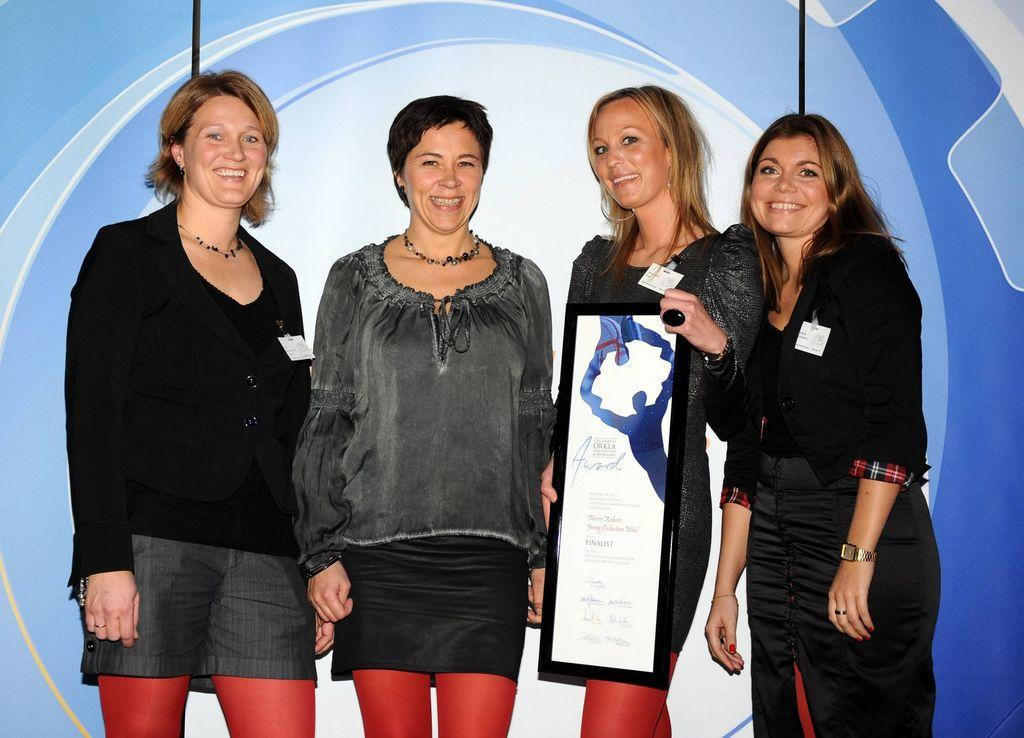What is happening in the image? There are people standing in the image. Can you describe what the woman is holding? The woman is holding a photo frame. What is written or printed on the photo frame? The photo frame has text on it. What can be seen in the background of the image? There is a design on the wall in the background. How many pies are being served on the table in the image? There is no table or pies present in the image. 